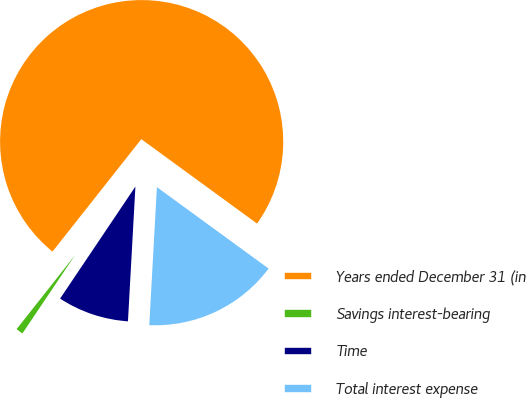Convert chart to OTSL. <chart><loc_0><loc_0><loc_500><loc_500><pie_chart><fcel>Years ended December 31 (in<fcel>Savings interest-bearing<fcel>Time<fcel>Total interest expense<nl><fcel>74.39%<fcel>1.22%<fcel>8.54%<fcel>15.85%<nl></chart> 